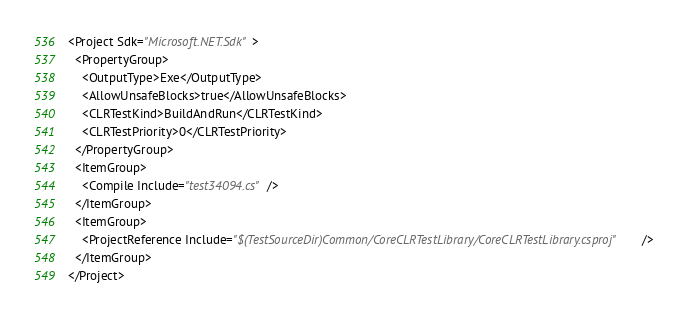Convert code to text. <code><loc_0><loc_0><loc_500><loc_500><_XML_><Project Sdk="Microsoft.NET.Sdk">
  <PropertyGroup>
    <OutputType>Exe</OutputType>
    <AllowUnsafeBlocks>true</AllowUnsafeBlocks>
    <CLRTestKind>BuildAndRun</CLRTestKind>
    <CLRTestPriority>0</CLRTestPriority>
  </PropertyGroup>
  <ItemGroup>
    <Compile Include="test34094.cs" />
  </ItemGroup>
  <ItemGroup>
    <ProjectReference Include="$(TestSourceDir)Common/CoreCLRTestLibrary/CoreCLRTestLibrary.csproj" />
  </ItemGroup>
</Project>
</code> 